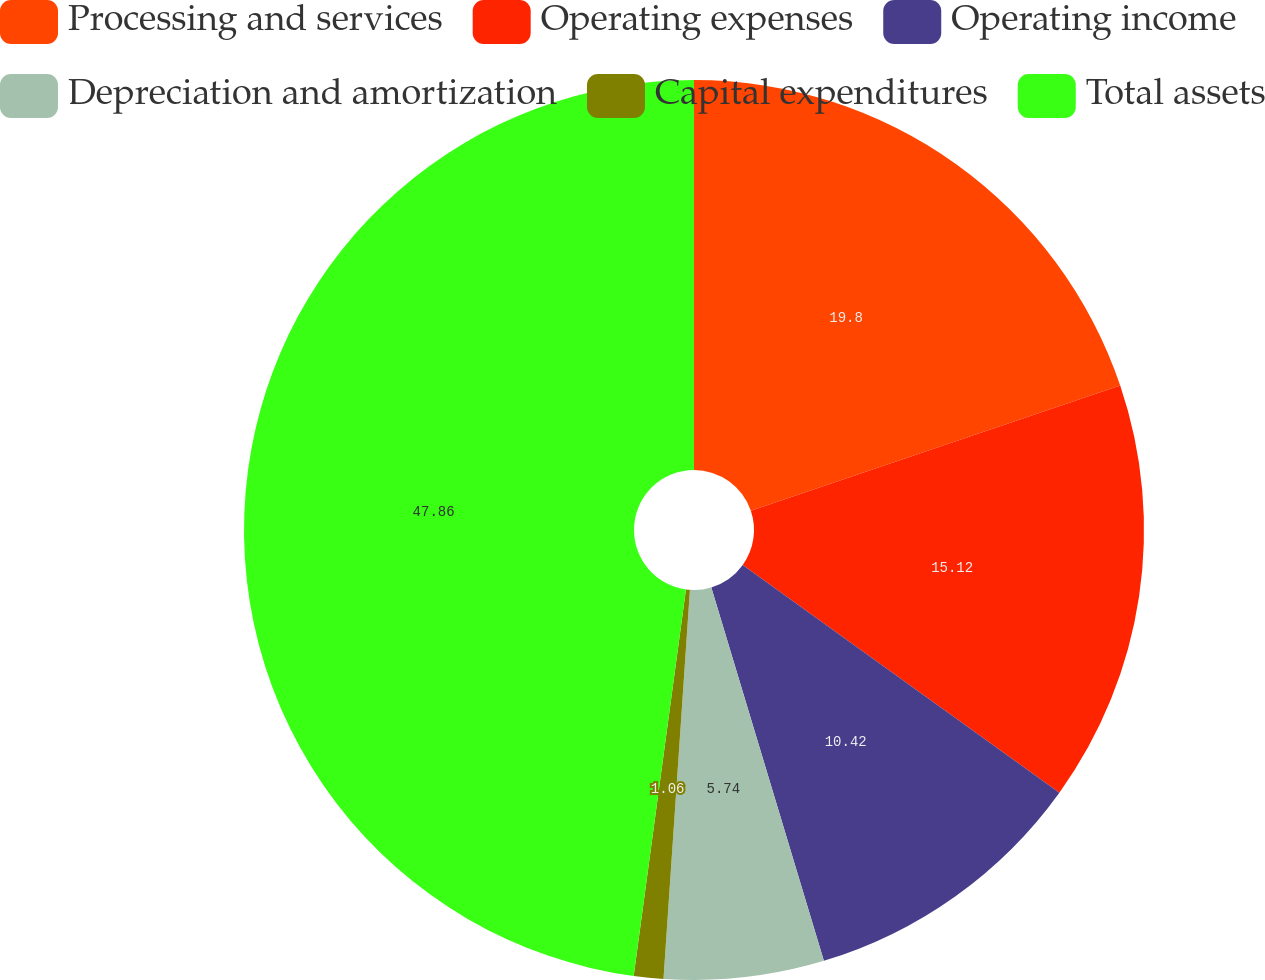<chart> <loc_0><loc_0><loc_500><loc_500><pie_chart><fcel>Processing and services<fcel>Operating expenses<fcel>Operating income<fcel>Depreciation and amortization<fcel>Capital expenditures<fcel>Total assets<nl><fcel>19.8%<fcel>15.12%<fcel>10.42%<fcel>5.74%<fcel>1.06%<fcel>47.86%<nl></chart> 